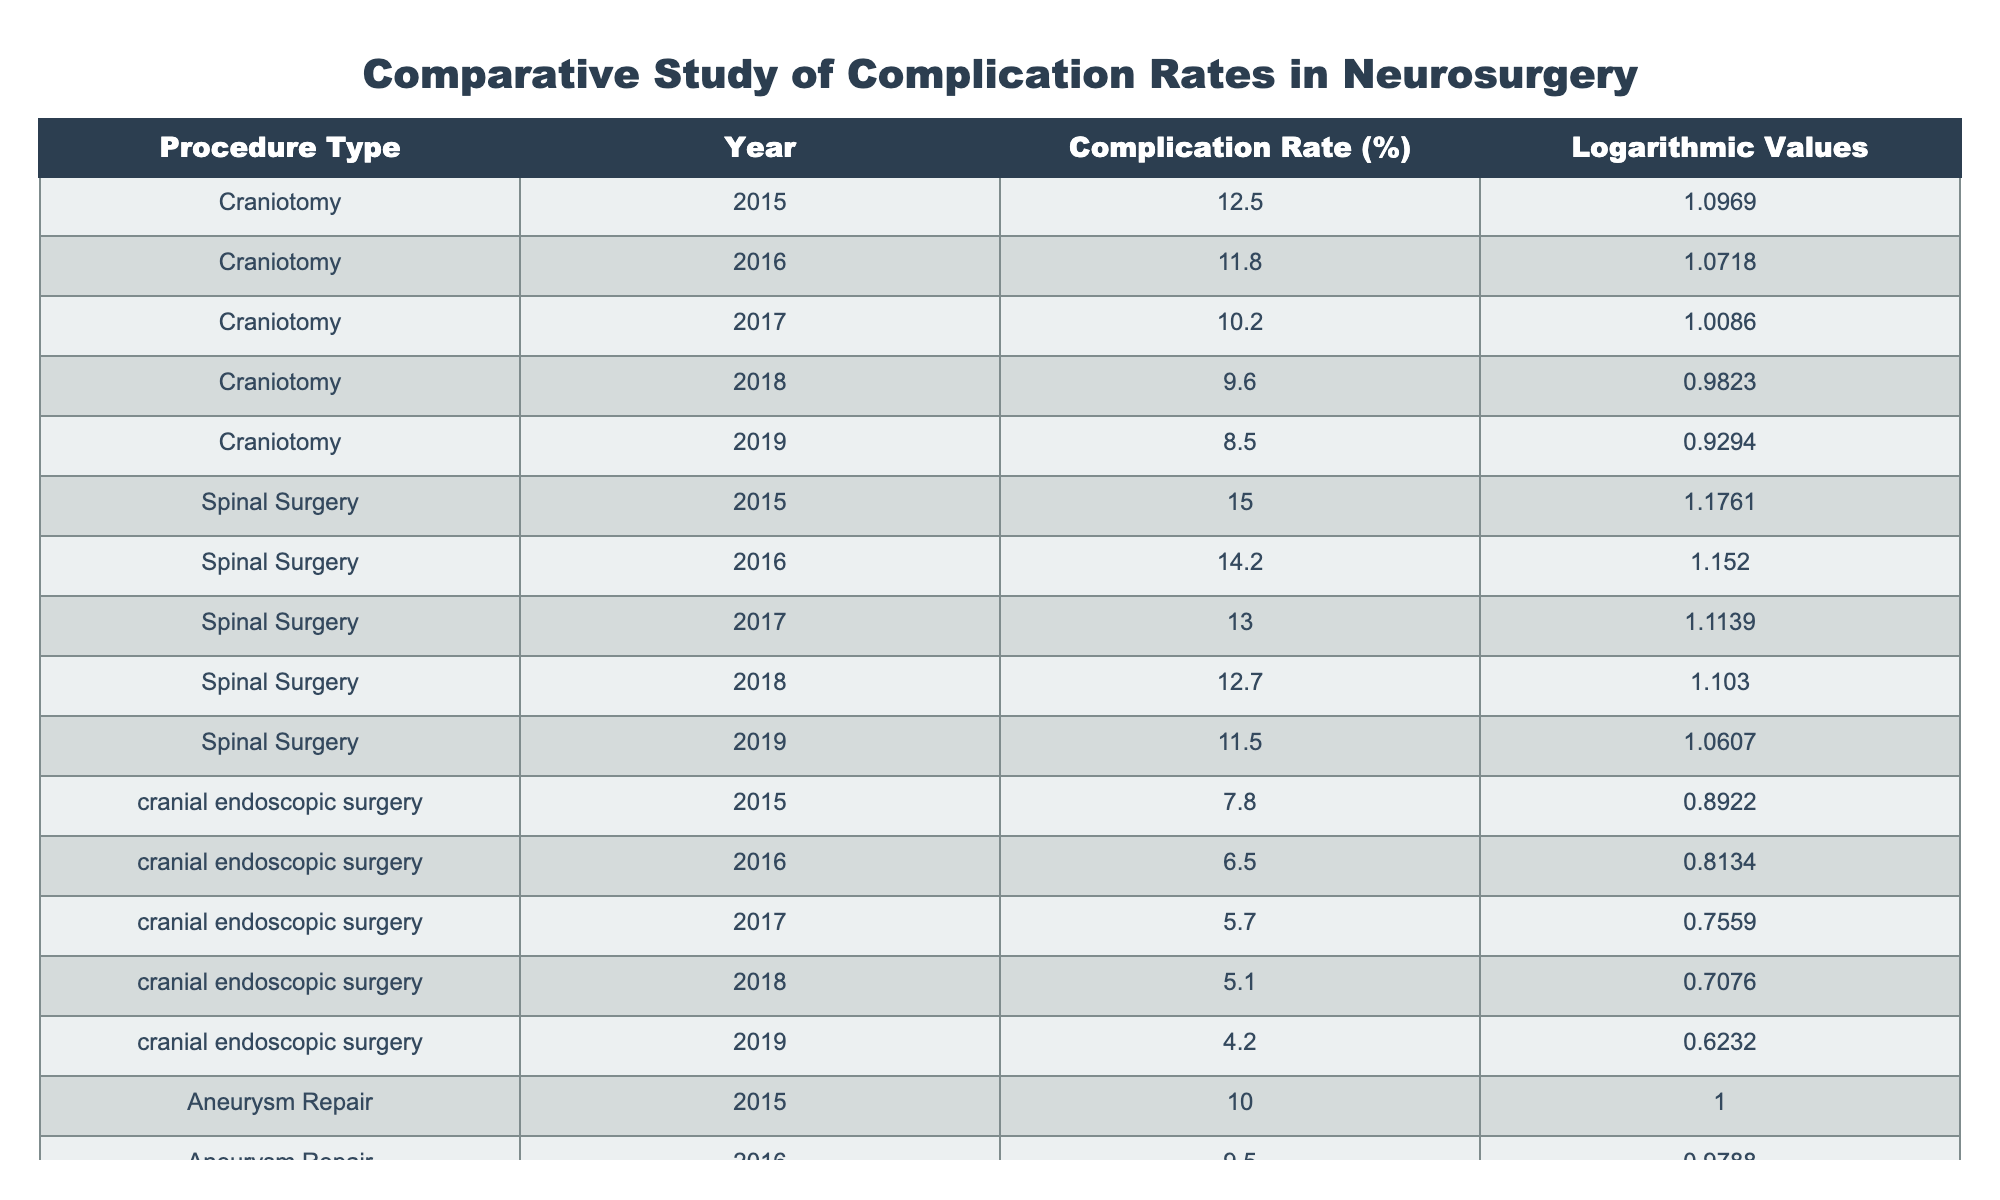What was the complication rate for craniotomy in 2019? Referring to the table, the complication rate for craniotomy in 2019 is directly stated. Under the "Complication Rate (%)" column for "Craniotomy" and the year "2019", the value is 8.5.
Answer: 8.5 Which procedure type had the highest complication rate in 2016? The table shows the complication rates for all procedure types in 2016. The rates for Craniotomy, Spinal Surgery, cranial endoscopic surgery, and Aneurysm Repair in 2016 are 11.8%, 14.2%, 6.5%, and 9.5% respectively. The highest among these is 14.2%, which corresponds to Spinal Surgery.
Answer: Spinal Surgery What is the average complication rate for cranial endoscopic surgery over the years provided? The complication rates for cranial endoscopic surgery from 2015 to 2019 are 7.8%, 6.5%, 5.7%, 5.1%, and 4.2%. Adding these rates gives a sum of 29.3%. Divided by the number of years (5), the average is 29.3/5 = 5.86%.
Answer: 5.86 Did Aneurysm Repair have a decreasing complication rate from 2015 to 2019? By looking at the complication rates for Aneurysm Repair from 2015 (10.0%) to 2019 (6.7%), it is evident that the rates consistently decreased each year: 10.0 → 9.5 → 8.3 → 7.9 → 6.7. Therefore, the statement is true.
Answer: Yes Which year saw the lowest complication rate for spinal surgery? In the table, the complication rates for Spinal Surgery by year are as follows: 15.0 (2015), 14.2 (2016), 13.0 (2017), 12.7 (2018), and 11.5 (2019). The lowest rate is found in 2019, which is 11.5%.
Answer: 11.5% What is the difference in complication rates between cranial endoscopic surgery and Aneurysm Repair in 2017? In 2017, the complication rate for cranial endoscopic surgery is 5.7% and for Aneurysm Repair, it is 8.3%. The difference is calculated by subtracting: 8.3% - 5.7% = 2.6%.
Answer: 2.6% Was the complication rate for craniotomy lower than that of spinal surgery in 2018? The complication rate for craniotomy in 2018 is 9.6%, while for spinal surgery, it is 12.7%. Because 9.6% is less than 12.7%, the statement is true.
Answer: Yes What trend can be observed for cranial endoscopic surgery from 2015 to 2019? The complication rates for cranial endoscopic surgery are 7.8%, 6.5%, 5.7%, 5.1%, and 4.2% respectively. These values indicate a consistent downward trend over the years.
Answer: Decreasing trend 